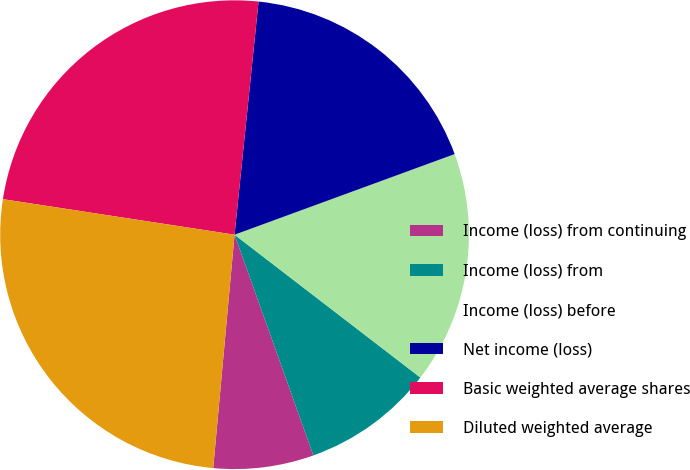Convert chart. <chart><loc_0><loc_0><loc_500><loc_500><pie_chart><fcel>Income (loss) from continuing<fcel>Income (loss) from<fcel>Income (loss) before<fcel>Net income (loss)<fcel>Basic weighted average shares<fcel>Diluted weighted average<nl><fcel>6.91%<fcel>9.11%<fcel>16.02%<fcel>17.78%<fcel>24.21%<fcel>25.97%<nl></chart> 